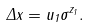Convert formula to latex. <formula><loc_0><loc_0><loc_500><loc_500>\Delta x = u _ { 1 } \sigma ^ { z _ { 1 } } .</formula> 